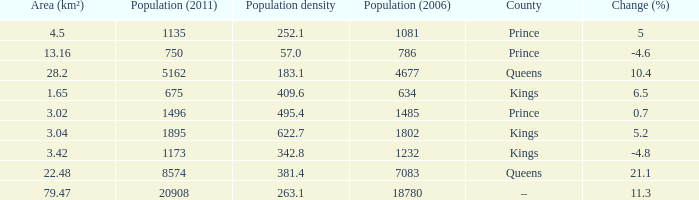What was the Population (2011) when the Population (2006) was less than 7083, and the Population density less than 342.8, and the Change (%) of 5, and an Area (km²) larger than 4.5? 0.0. 